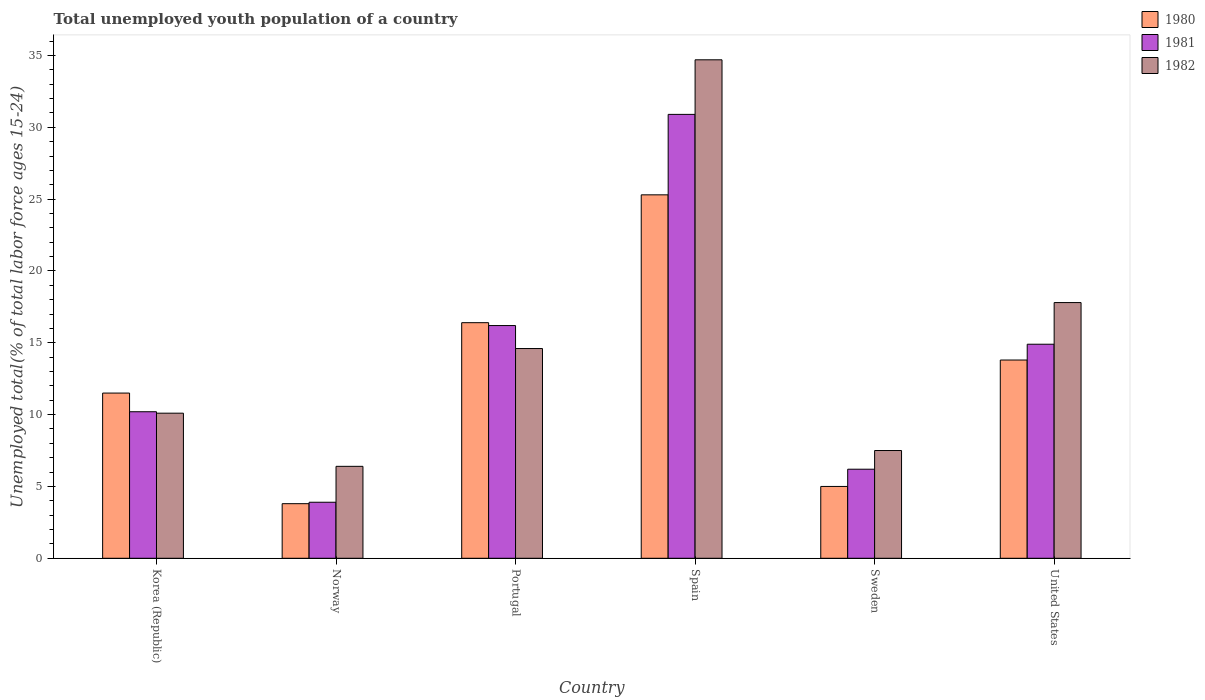How many different coloured bars are there?
Provide a short and direct response. 3. How many groups of bars are there?
Provide a short and direct response. 6. Are the number of bars per tick equal to the number of legend labels?
Offer a terse response. Yes. How many bars are there on the 2nd tick from the left?
Your answer should be very brief. 3. How many bars are there on the 3rd tick from the right?
Give a very brief answer. 3. What is the label of the 3rd group of bars from the left?
Ensure brevity in your answer.  Portugal. What is the percentage of total unemployed youth population of a country in 1980 in Norway?
Your response must be concise. 3.8. Across all countries, what is the maximum percentage of total unemployed youth population of a country in 1981?
Your response must be concise. 30.9. Across all countries, what is the minimum percentage of total unemployed youth population of a country in 1980?
Your answer should be very brief. 3.8. In which country was the percentage of total unemployed youth population of a country in 1982 maximum?
Provide a short and direct response. Spain. What is the total percentage of total unemployed youth population of a country in 1982 in the graph?
Provide a succinct answer. 91.1. What is the difference between the percentage of total unemployed youth population of a country in 1980 in Sweden and that in United States?
Offer a very short reply. -8.8. What is the difference between the percentage of total unemployed youth population of a country in 1980 in Norway and the percentage of total unemployed youth population of a country in 1982 in Portugal?
Make the answer very short. -10.8. What is the average percentage of total unemployed youth population of a country in 1981 per country?
Give a very brief answer. 13.72. What is the difference between the percentage of total unemployed youth population of a country of/in 1982 and percentage of total unemployed youth population of a country of/in 1980 in United States?
Your answer should be compact. 4. In how many countries, is the percentage of total unemployed youth population of a country in 1981 greater than 18 %?
Your response must be concise. 1. What is the ratio of the percentage of total unemployed youth population of a country in 1982 in Norway to that in Sweden?
Provide a succinct answer. 0.85. Is the difference between the percentage of total unemployed youth population of a country in 1982 in Korea (Republic) and Spain greater than the difference between the percentage of total unemployed youth population of a country in 1980 in Korea (Republic) and Spain?
Ensure brevity in your answer.  No. What is the difference between the highest and the second highest percentage of total unemployed youth population of a country in 1981?
Offer a very short reply. -14.7. What is the difference between the highest and the lowest percentage of total unemployed youth population of a country in 1981?
Provide a short and direct response. 27. In how many countries, is the percentage of total unemployed youth population of a country in 1981 greater than the average percentage of total unemployed youth population of a country in 1981 taken over all countries?
Your response must be concise. 3. What does the 1st bar from the left in Portugal represents?
Provide a succinct answer. 1980. Is it the case that in every country, the sum of the percentage of total unemployed youth population of a country in 1981 and percentage of total unemployed youth population of a country in 1980 is greater than the percentage of total unemployed youth population of a country in 1982?
Offer a terse response. Yes. How many countries are there in the graph?
Provide a short and direct response. 6. What is the difference between two consecutive major ticks on the Y-axis?
Provide a succinct answer. 5. Does the graph contain any zero values?
Make the answer very short. No. Where does the legend appear in the graph?
Ensure brevity in your answer.  Top right. How many legend labels are there?
Ensure brevity in your answer.  3. How are the legend labels stacked?
Your answer should be compact. Vertical. What is the title of the graph?
Your response must be concise. Total unemployed youth population of a country. What is the label or title of the X-axis?
Offer a very short reply. Country. What is the label or title of the Y-axis?
Your response must be concise. Unemployed total(% of total labor force ages 15-24). What is the Unemployed total(% of total labor force ages 15-24) in 1980 in Korea (Republic)?
Your response must be concise. 11.5. What is the Unemployed total(% of total labor force ages 15-24) in 1981 in Korea (Republic)?
Keep it short and to the point. 10.2. What is the Unemployed total(% of total labor force ages 15-24) of 1982 in Korea (Republic)?
Your answer should be compact. 10.1. What is the Unemployed total(% of total labor force ages 15-24) of 1980 in Norway?
Offer a very short reply. 3.8. What is the Unemployed total(% of total labor force ages 15-24) in 1981 in Norway?
Give a very brief answer. 3.9. What is the Unemployed total(% of total labor force ages 15-24) of 1982 in Norway?
Your response must be concise. 6.4. What is the Unemployed total(% of total labor force ages 15-24) of 1980 in Portugal?
Provide a short and direct response. 16.4. What is the Unemployed total(% of total labor force ages 15-24) in 1981 in Portugal?
Provide a succinct answer. 16.2. What is the Unemployed total(% of total labor force ages 15-24) of 1982 in Portugal?
Keep it short and to the point. 14.6. What is the Unemployed total(% of total labor force ages 15-24) of 1980 in Spain?
Make the answer very short. 25.3. What is the Unemployed total(% of total labor force ages 15-24) of 1981 in Spain?
Your answer should be compact. 30.9. What is the Unemployed total(% of total labor force ages 15-24) of 1982 in Spain?
Provide a succinct answer. 34.7. What is the Unemployed total(% of total labor force ages 15-24) in 1981 in Sweden?
Offer a very short reply. 6.2. What is the Unemployed total(% of total labor force ages 15-24) in 1982 in Sweden?
Your response must be concise. 7.5. What is the Unemployed total(% of total labor force ages 15-24) in 1980 in United States?
Offer a terse response. 13.8. What is the Unemployed total(% of total labor force ages 15-24) in 1981 in United States?
Your answer should be very brief. 14.9. What is the Unemployed total(% of total labor force ages 15-24) in 1982 in United States?
Provide a short and direct response. 17.8. Across all countries, what is the maximum Unemployed total(% of total labor force ages 15-24) in 1980?
Offer a terse response. 25.3. Across all countries, what is the maximum Unemployed total(% of total labor force ages 15-24) of 1981?
Offer a very short reply. 30.9. Across all countries, what is the maximum Unemployed total(% of total labor force ages 15-24) in 1982?
Ensure brevity in your answer.  34.7. Across all countries, what is the minimum Unemployed total(% of total labor force ages 15-24) of 1980?
Offer a very short reply. 3.8. Across all countries, what is the minimum Unemployed total(% of total labor force ages 15-24) in 1981?
Ensure brevity in your answer.  3.9. Across all countries, what is the minimum Unemployed total(% of total labor force ages 15-24) of 1982?
Provide a succinct answer. 6.4. What is the total Unemployed total(% of total labor force ages 15-24) in 1980 in the graph?
Provide a succinct answer. 75.8. What is the total Unemployed total(% of total labor force ages 15-24) of 1981 in the graph?
Provide a short and direct response. 82.3. What is the total Unemployed total(% of total labor force ages 15-24) in 1982 in the graph?
Provide a succinct answer. 91.1. What is the difference between the Unemployed total(% of total labor force ages 15-24) of 1982 in Korea (Republic) and that in Norway?
Your response must be concise. 3.7. What is the difference between the Unemployed total(% of total labor force ages 15-24) in 1981 in Korea (Republic) and that in Portugal?
Your answer should be compact. -6. What is the difference between the Unemployed total(% of total labor force ages 15-24) of 1980 in Korea (Republic) and that in Spain?
Keep it short and to the point. -13.8. What is the difference between the Unemployed total(% of total labor force ages 15-24) of 1981 in Korea (Republic) and that in Spain?
Make the answer very short. -20.7. What is the difference between the Unemployed total(% of total labor force ages 15-24) in 1982 in Korea (Republic) and that in Spain?
Offer a very short reply. -24.6. What is the difference between the Unemployed total(% of total labor force ages 15-24) of 1981 in Korea (Republic) and that in United States?
Provide a succinct answer. -4.7. What is the difference between the Unemployed total(% of total labor force ages 15-24) of 1982 in Norway and that in Portugal?
Ensure brevity in your answer.  -8.2. What is the difference between the Unemployed total(% of total labor force ages 15-24) in 1980 in Norway and that in Spain?
Offer a very short reply. -21.5. What is the difference between the Unemployed total(% of total labor force ages 15-24) of 1982 in Norway and that in Spain?
Your answer should be very brief. -28.3. What is the difference between the Unemployed total(% of total labor force ages 15-24) of 1981 in Norway and that in Sweden?
Provide a succinct answer. -2.3. What is the difference between the Unemployed total(% of total labor force ages 15-24) in 1982 in Norway and that in Sweden?
Ensure brevity in your answer.  -1.1. What is the difference between the Unemployed total(% of total labor force ages 15-24) of 1982 in Norway and that in United States?
Offer a terse response. -11.4. What is the difference between the Unemployed total(% of total labor force ages 15-24) in 1981 in Portugal and that in Spain?
Provide a succinct answer. -14.7. What is the difference between the Unemployed total(% of total labor force ages 15-24) of 1982 in Portugal and that in Spain?
Your response must be concise. -20.1. What is the difference between the Unemployed total(% of total labor force ages 15-24) of 1980 in Portugal and that in Sweden?
Your answer should be compact. 11.4. What is the difference between the Unemployed total(% of total labor force ages 15-24) in 1981 in Portugal and that in Sweden?
Your response must be concise. 10. What is the difference between the Unemployed total(% of total labor force ages 15-24) in 1980 in Portugal and that in United States?
Keep it short and to the point. 2.6. What is the difference between the Unemployed total(% of total labor force ages 15-24) of 1981 in Portugal and that in United States?
Your answer should be very brief. 1.3. What is the difference between the Unemployed total(% of total labor force ages 15-24) in 1982 in Portugal and that in United States?
Offer a very short reply. -3.2. What is the difference between the Unemployed total(% of total labor force ages 15-24) in 1980 in Spain and that in Sweden?
Make the answer very short. 20.3. What is the difference between the Unemployed total(% of total labor force ages 15-24) of 1981 in Spain and that in Sweden?
Provide a short and direct response. 24.7. What is the difference between the Unemployed total(% of total labor force ages 15-24) in 1982 in Spain and that in Sweden?
Ensure brevity in your answer.  27.2. What is the difference between the Unemployed total(% of total labor force ages 15-24) in 1980 in Spain and that in United States?
Offer a very short reply. 11.5. What is the difference between the Unemployed total(% of total labor force ages 15-24) of 1980 in Korea (Republic) and the Unemployed total(% of total labor force ages 15-24) of 1981 in Norway?
Offer a very short reply. 7.6. What is the difference between the Unemployed total(% of total labor force ages 15-24) in 1980 in Korea (Republic) and the Unemployed total(% of total labor force ages 15-24) in 1981 in Spain?
Provide a short and direct response. -19.4. What is the difference between the Unemployed total(% of total labor force ages 15-24) in 1980 in Korea (Republic) and the Unemployed total(% of total labor force ages 15-24) in 1982 in Spain?
Keep it short and to the point. -23.2. What is the difference between the Unemployed total(% of total labor force ages 15-24) in 1981 in Korea (Republic) and the Unemployed total(% of total labor force ages 15-24) in 1982 in Spain?
Your answer should be very brief. -24.5. What is the difference between the Unemployed total(% of total labor force ages 15-24) of 1981 in Korea (Republic) and the Unemployed total(% of total labor force ages 15-24) of 1982 in Sweden?
Your answer should be compact. 2.7. What is the difference between the Unemployed total(% of total labor force ages 15-24) in 1981 in Korea (Republic) and the Unemployed total(% of total labor force ages 15-24) in 1982 in United States?
Your answer should be very brief. -7.6. What is the difference between the Unemployed total(% of total labor force ages 15-24) in 1981 in Norway and the Unemployed total(% of total labor force ages 15-24) in 1982 in Portugal?
Make the answer very short. -10.7. What is the difference between the Unemployed total(% of total labor force ages 15-24) in 1980 in Norway and the Unemployed total(% of total labor force ages 15-24) in 1981 in Spain?
Provide a short and direct response. -27.1. What is the difference between the Unemployed total(% of total labor force ages 15-24) in 1980 in Norway and the Unemployed total(% of total labor force ages 15-24) in 1982 in Spain?
Your response must be concise. -30.9. What is the difference between the Unemployed total(% of total labor force ages 15-24) in 1981 in Norway and the Unemployed total(% of total labor force ages 15-24) in 1982 in Spain?
Your answer should be compact. -30.8. What is the difference between the Unemployed total(% of total labor force ages 15-24) in 1980 in Norway and the Unemployed total(% of total labor force ages 15-24) in 1982 in Sweden?
Your answer should be compact. -3.7. What is the difference between the Unemployed total(% of total labor force ages 15-24) of 1981 in Norway and the Unemployed total(% of total labor force ages 15-24) of 1982 in Sweden?
Give a very brief answer. -3.6. What is the difference between the Unemployed total(% of total labor force ages 15-24) in 1980 in Norway and the Unemployed total(% of total labor force ages 15-24) in 1981 in United States?
Your response must be concise. -11.1. What is the difference between the Unemployed total(% of total labor force ages 15-24) of 1981 in Norway and the Unemployed total(% of total labor force ages 15-24) of 1982 in United States?
Provide a short and direct response. -13.9. What is the difference between the Unemployed total(% of total labor force ages 15-24) of 1980 in Portugal and the Unemployed total(% of total labor force ages 15-24) of 1981 in Spain?
Make the answer very short. -14.5. What is the difference between the Unemployed total(% of total labor force ages 15-24) in 1980 in Portugal and the Unemployed total(% of total labor force ages 15-24) in 1982 in Spain?
Give a very brief answer. -18.3. What is the difference between the Unemployed total(% of total labor force ages 15-24) in 1981 in Portugal and the Unemployed total(% of total labor force ages 15-24) in 1982 in Spain?
Your answer should be very brief. -18.5. What is the difference between the Unemployed total(% of total labor force ages 15-24) of 1980 in Portugal and the Unemployed total(% of total labor force ages 15-24) of 1981 in United States?
Provide a short and direct response. 1.5. What is the difference between the Unemployed total(% of total labor force ages 15-24) in 1980 in Portugal and the Unemployed total(% of total labor force ages 15-24) in 1982 in United States?
Make the answer very short. -1.4. What is the difference between the Unemployed total(% of total labor force ages 15-24) in 1981 in Portugal and the Unemployed total(% of total labor force ages 15-24) in 1982 in United States?
Provide a succinct answer. -1.6. What is the difference between the Unemployed total(% of total labor force ages 15-24) of 1980 in Spain and the Unemployed total(% of total labor force ages 15-24) of 1981 in Sweden?
Make the answer very short. 19.1. What is the difference between the Unemployed total(% of total labor force ages 15-24) of 1981 in Spain and the Unemployed total(% of total labor force ages 15-24) of 1982 in Sweden?
Provide a short and direct response. 23.4. What is the difference between the Unemployed total(% of total labor force ages 15-24) of 1980 in Sweden and the Unemployed total(% of total labor force ages 15-24) of 1982 in United States?
Provide a short and direct response. -12.8. What is the difference between the Unemployed total(% of total labor force ages 15-24) of 1981 in Sweden and the Unemployed total(% of total labor force ages 15-24) of 1982 in United States?
Your response must be concise. -11.6. What is the average Unemployed total(% of total labor force ages 15-24) in 1980 per country?
Your answer should be very brief. 12.63. What is the average Unemployed total(% of total labor force ages 15-24) of 1981 per country?
Provide a succinct answer. 13.72. What is the average Unemployed total(% of total labor force ages 15-24) of 1982 per country?
Provide a succinct answer. 15.18. What is the difference between the Unemployed total(% of total labor force ages 15-24) of 1980 and Unemployed total(% of total labor force ages 15-24) of 1981 in Korea (Republic)?
Provide a short and direct response. 1.3. What is the difference between the Unemployed total(% of total labor force ages 15-24) in 1980 and Unemployed total(% of total labor force ages 15-24) in 1982 in Korea (Republic)?
Your answer should be very brief. 1.4. What is the difference between the Unemployed total(% of total labor force ages 15-24) of 1981 and Unemployed total(% of total labor force ages 15-24) of 1982 in Korea (Republic)?
Provide a succinct answer. 0.1. What is the difference between the Unemployed total(% of total labor force ages 15-24) in 1980 and Unemployed total(% of total labor force ages 15-24) in 1981 in Norway?
Offer a very short reply. -0.1. What is the difference between the Unemployed total(% of total labor force ages 15-24) of 1980 and Unemployed total(% of total labor force ages 15-24) of 1982 in Norway?
Provide a succinct answer. -2.6. What is the difference between the Unemployed total(% of total labor force ages 15-24) in 1981 and Unemployed total(% of total labor force ages 15-24) in 1982 in Portugal?
Offer a terse response. 1.6. What is the difference between the Unemployed total(% of total labor force ages 15-24) in 1980 and Unemployed total(% of total labor force ages 15-24) in 1981 in Spain?
Make the answer very short. -5.6. What is the difference between the Unemployed total(% of total labor force ages 15-24) of 1980 and Unemployed total(% of total labor force ages 15-24) of 1982 in Spain?
Your answer should be very brief. -9.4. What is the difference between the Unemployed total(% of total labor force ages 15-24) in 1980 and Unemployed total(% of total labor force ages 15-24) in 1982 in Sweden?
Your answer should be very brief. -2.5. What is the difference between the Unemployed total(% of total labor force ages 15-24) in 1980 and Unemployed total(% of total labor force ages 15-24) in 1981 in United States?
Keep it short and to the point. -1.1. What is the difference between the Unemployed total(% of total labor force ages 15-24) of 1981 and Unemployed total(% of total labor force ages 15-24) of 1982 in United States?
Keep it short and to the point. -2.9. What is the ratio of the Unemployed total(% of total labor force ages 15-24) of 1980 in Korea (Republic) to that in Norway?
Provide a short and direct response. 3.03. What is the ratio of the Unemployed total(% of total labor force ages 15-24) in 1981 in Korea (Republic) to that in Norway?
Your answer should be very brief. 2.62. What is the ratio of the Unemployed total(% of total labor force ages 15-24) of 1982 in Korea (Republic) to that in Norway?
Make the answer very short. 1.58. What is the ratio of the Unemployed total(% of total labor force ages 15-24) of 1980 in Korea (Republic) to that in Portugal?
Your response must be concise. 0.7. What is the ratio of the Unemployed total(% of total labor force ages 15-24) of 1981 in Korea (Republic) to that in Portugal?
Your response must be concise. 0.63. What is the ratio of the Unemployed total(% of total labor force ages 15-24) in 1982 in Korea (Republic) to that in Portugal?
Keep it short and to the point. 0.69. What is the ratio of the Unemployed total(% of total labor force ages 15-24) of 1980 in Korea (Republic) to that in Spain?
Your response must be concise. 0.45. What is the ratio of the Unemployed total(% of total labor force ages 15-24) of 1981 in Korea (Republic) to that in Spain?
Offer a very short reply. 0.33. What is the ratio of the Unemployed total(% of total labor force ages 15-24) in 1982 in Korea (Republic) to that in Spain?
Your answer should be compact. 0.29. What is the ratio of the Unemployed total(% of total labor force ages 15-24) in 1981 in Korea (Republic) to that in Sweden?
Provide a succinct answer. 1.65. What is the ratio of the Unemployed total(% of total labor force ages 15-24) in 1982 in Korea (Republic) to that in Sweden?
Ensure brevity in your answer.  1.35. What is the ratio of the Unemployed total(% of total labor force ages 15-24) in 1981 in Korea (Republic) to that in United States?
Make the answer very short. 0.68. What is the ratio of the Unemployed total(% of total labor force ages 15-24) in 1982 in Korea (Republic) to that in United States?
Provide a succinct answer. 0.57. What is the ratio of the Unemployed total(% of total labor force ages 15-24) in 1980 in Norway to that in Portugal?
Offer a terse response. 0.23. What is the ratio of the Unemployed total(% of total labor force ages 15-24) in 1981 in Norway to that in Portugal?
Offer a very short reply. 0.24. What is the ratio of the Unemployed total(% of total labor force ages 15-24) in 1982 in Norway to that in Portugal?
Your response must be concise. 0.44. What is the ratio of the Unemployed total(% of total labor force ages 15-24) of 1980 in Norway to that in Spain?
Provide a succinct answer. 0.15. What is the ratio of the Unemployed total(% of total labor force ages 15-24) of 1981 in Norway to that in Spain?
Keep it short and to the point. 0.13. What is the ratio of the Unemployed total(% of total labor force ages 15-24) of 1982 in Norway to that in Spain?
Your answer should be very brief. 0.18. What is the ratio of the Unemployed total(% of total labor force ages 15-24) in 1980 in Norway to that in Sweden?
Your answer should be compact. 0.76. What is the ratio of the Unemployed total(% of total labor force ages 15-24) in 1981 in Norway to that in Sweden?
Make the answer very short. 0.63. What is the ratio of the Unemployed total(% of total labor force ages 15-24) in 1982 in Norway to that in Sweden?
Provide a succinct answer. 0.85. What is the ratio of the Unemployed total(% of total labor force ages 15-24) of 1980 in Norway to that in United States?
Keep it short and to the point. 0.28. What is the ratio of the Unemployed total(% of total labor force ages 15-24) in 1981 in Norway to that in United States?
Give a very brief answer. 0.26. What is the ratio of the Unemployed total(% of total labor force ages 15-24) in 1982 in Norway to that in United States?
Your response must be concise. 0.36. What is the ratio of the Unemployed total(% of total labor force ages 15-24) in 1980 in Portugal to that in Spain?
Your answer should be very brief. 0.65. What is the ratio of the Unemployed total(% of total labor force ages 15-24) in 1981 in Portugal to that in Spain?
Offer a terse response. 0.52. What is the ratio of the Unemployed total(% of total labor force ages 15-24) of 1982 in Portugal to that in Spain?
Your response must be concise. 0.42. What is the ratio of the Unemployed total(% of total labor force ages 15-24) of 1980 in Portugal to that in Sweden?
Provide a succinct answer. 3.28. What is the ratio of the Unemployed total(% of total labor force ages 15-24) in 1981 in Portugal to that in Sweden?
Your response must be concise. 2.61. What is the ratio of the Unemployed total(% of total labor force ages 15-24) of 1982 in Portugal to that in Sweden?
Offer a very short reply. 1.95. What is the ratio of the Unemployed total(% of total labor force ages 15-24) in 1980 in Portugal to that in United States?
Your answer should be very brief. 1.19. What is the ratio of the Unemployed total(% of total labor force ages 15-24) in 1981 in Portugal to that in United States?
Your answer should be very brief. 1.09. What is the ratio of the Unemployed total(% of total labor force ages 15-24) of 1982 in Portugal to that in United States?
Your answer should be very brief. 0.82. What is the ratio of the Unemployed total(% of total labor force ages 15-24) of 1980 in Spain to that in Sweden?
Offer a very short reply. 5.06. What is the ratio of the Unemployed total(% of total labor force ages 15-24) in 1981 in Spain to that in Sweden?
Provide a succinct answer. 4.98. What is the ratio of the Unemployed total(% of total labor force ages 15-24) of 1982 in Spain to that in Sweden?
Your answer should be very brief. 4.63. What is the ratio of the Unemployed total(% of total labor force ages 15-24) in 1980 in Spain to that in United States?
Give a very brief answer. 1.83. What is the ratio of the Unemployed total(% of total labor force ages 15-24) of 1981 in Spain to that in United States?
Keep it short and to the point. 2.07. What is the ratio of the Unemployed total(% of total labor force ages 15-24) in 1982 in Spain to that in United States?
Your answer should be very brief. 1.95. What is the ratio of the Unemployed total(% of total labor force ages 15-24) of 1980 in Sweden to that in United States?
Offer a very short reply. 0.36. What is the ratio of the Unemployed total(% of total labor force ages 15-24) of 1981 in Sweden to that in United States?
Ensure brevity in your answer.  0.42. What is the ratio of the Unemployed total(% of total labor force ages 15-24) in 1982 in Sweden to that in United States?
Your answer should be very brief. 0.42. What is the difference between the highest and the second highest Unemployed total(% of total labor force ages 15-24) of 1980?
Give a very brief answer. 8.9. What is the difference between the highest and the second highest Unemployed total(% of total labor force ages 15-24) of 1981?
Your answer should be very brief. 14.7. What is the difference between the highest and the lowest Unemployed total(% of total labor force ages 15-24) in 1980?
Provide a succinct answer. 21.5. What is the difference between the highest and the lowest Unemployed total(% of total labor force ages 15-24) of 1981?
Make the answer very short. 27. What is the difference between the highest and the lowest Unemployed total(% of total labor force ages 15-24) in 1982?
Give a very brief answer. 28.3. 